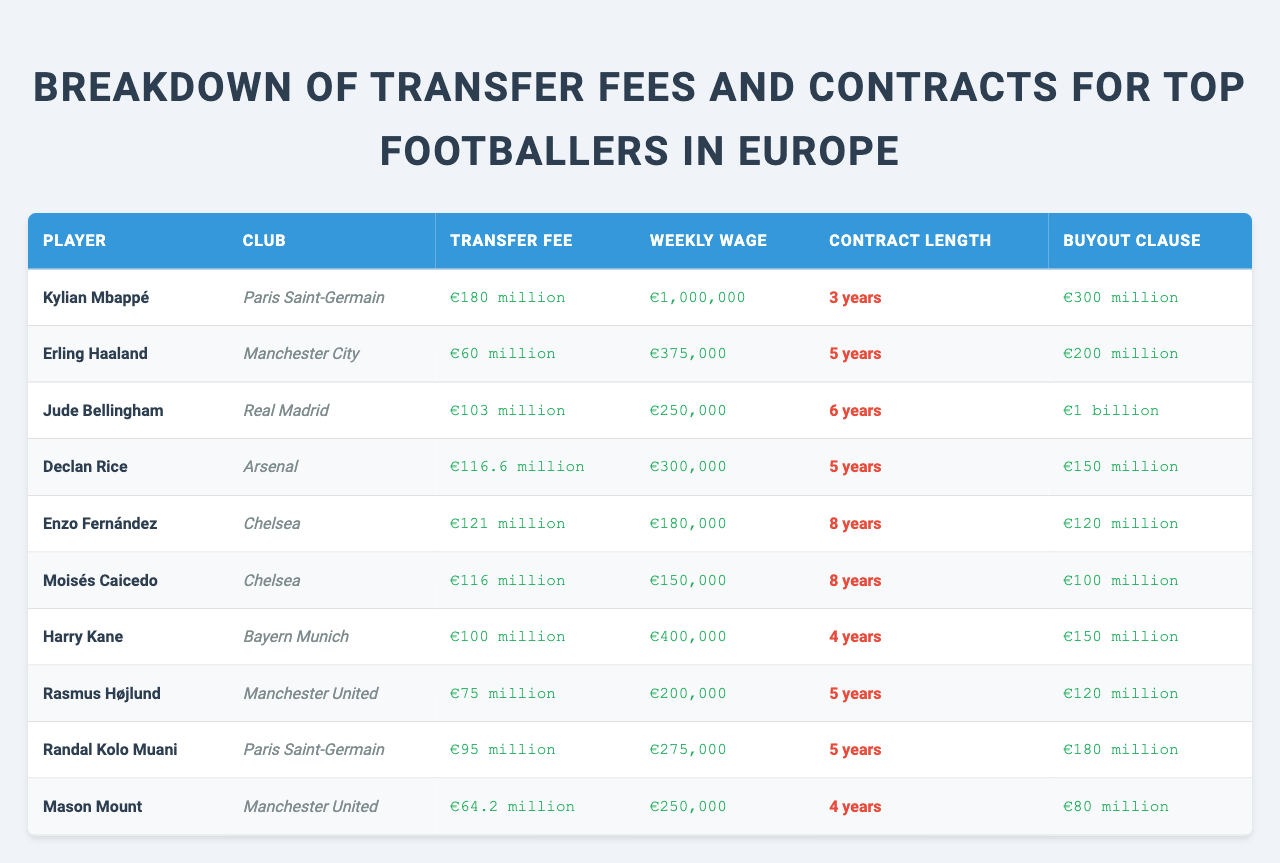What is the transfer fee for Kylian Mbappé? The table lists Kylian Mbappé's transfer fee under the "Transfer Fee" column, which shows €180 million.
Answer: €180 million Which player has the highest weekly wage? By comparing the "Weekly Wage" values in the table, Kylian Mbappé has the highest weekly wage at €1,000,000.
Answer: Kylian Mbappé How many years is Declan Rice's contract? The "Contract Length" column indicates that Declan Rice's contract length is 5 years.
Answer: 5 years What is the total transfer fee of players from Chelsea? The players from Chelsea and their transfer fees are listed: Enzo Fernández (€121 million) and Moisés Caicedo (€116 million), which sums up to €121 million + €116 million = €237 million.
Answer: €237 million Is Jude Bellingham's buyout clause greater than that of Erling Haaland? Jude Bellingham has a buyout clause of €1 billion, while Erling Haaland's buyout clause is €200 million. Since €1 billion is greater than €200 million, the statement is true.
Answer: Yes What is the average transfer fee of all listed players? To find the average, sum all the transfer fees (€180 million + €60 million + €103 million + €116.6 million + €121 million + €116 million + €100 million + €75 million + €95 million + €64.2 million = €1,007.8 million) and divide by the number of players (10), resulting in an average of €100.78 million.
Answer: €100.78 million Which player plays for Bayern Munich? The table specifies that Harry Kane plays for Bayern Munich.
Answer: Harry Kane How does Rasmus Højlund's transfer fee compare to Harry Kane's? Rasmus Højlund's transfer fee is €75 million, while Harry Kane's is €100 million. Since €75 million is less than €100 million, Rasmus Højlund has a lower transfer fee than Harry Kane.
Answer: Lower What is the total weekly wage for the players in Manchester United? The table states Manchester United has Rasmus Højlund (€200,000) and Mason Mount (€250,000), totaling €200,000 + €250,000 = €450,000.
Answer: €450,000 Which club has the longest contract among the players? Looking at the "Contract Length" column, Enzo Fernández and Moisés Caicedo both have 8 years, which is the longest contract length in the table.
Answer: Chelsea 